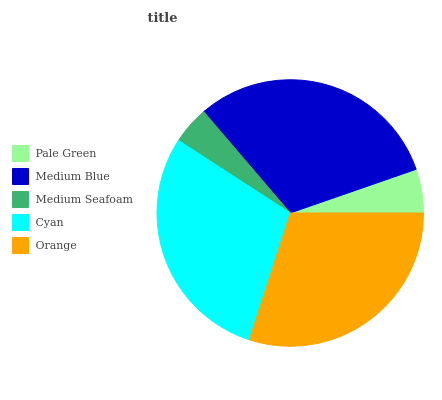Is Medium Seafoam the minimum?
Answer yes or no. Yes. Is Medium Blue the maximum?
Answer yes or no. Yes. Is Medium Blue the minimum?
Answer yes or no. No. Is Medium Seafoam the maximum?
Answer yes or no. No. Is Medium Blue greater than Medium Seafoam?
Answer yes or no. Yes. Is Medium Seafoam less than Medium Blue?
Answer yes or no. Yes. Is Medium Seafoam greater than Medium Blue?
Answer yes or no. No. Is Medium Blue less than Medium Seafoam?
Answer yes or no. No. Is Cyan the high median?
Answer yes or no. Yes. Is Cyan the low median?
Answer yes or no. Yes. Is Medium Seafoam the high median?
Answer yes or no. No. Is Medium Blue the low median?
Answer yes or no. No. 